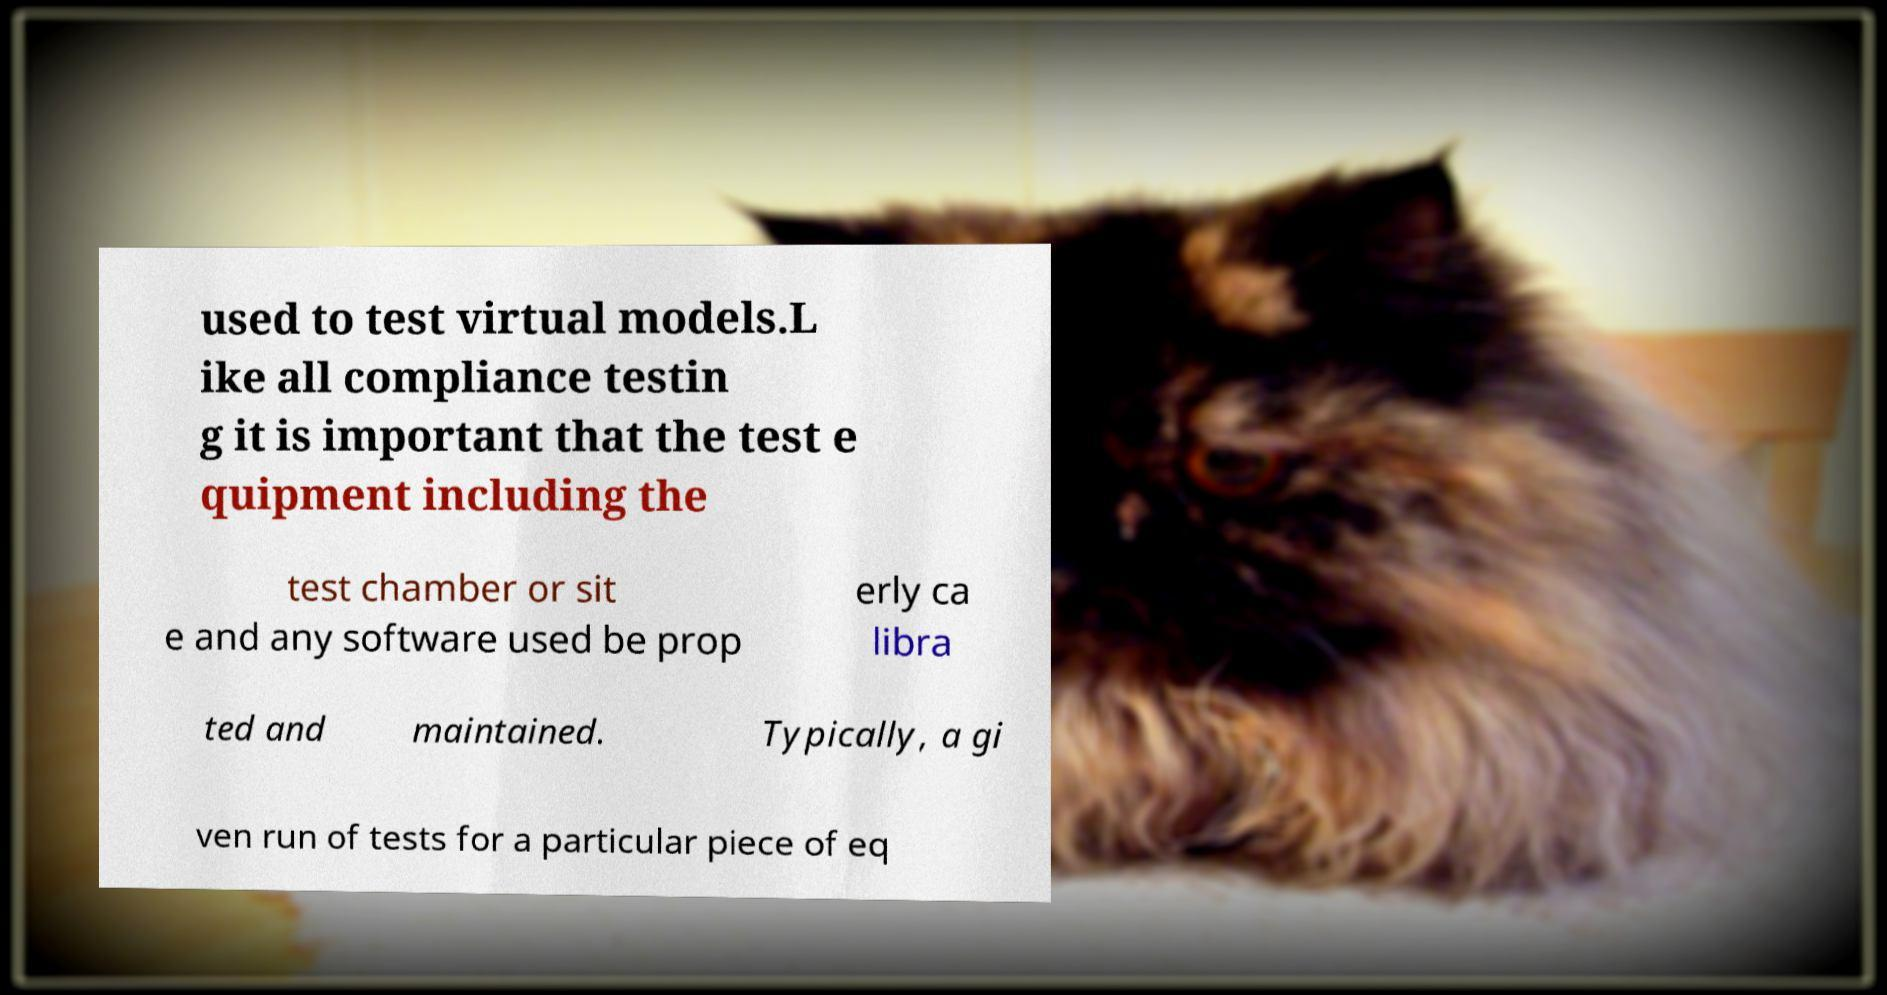For documentation purposes, I need the text within this image transcribed. Could you provide that? used to test virtual models.L ike all compliance testin g it is important that the test e quipment including the test chamber or sit e and any software used be prop erly ca libra ted and maintained. Typically, a gi ven run of tests for a particular piece of eq 